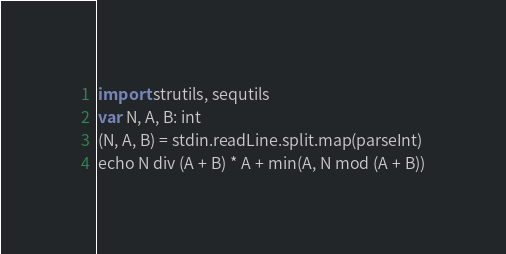Convert code to text. <code><loc_0><loc_0><loc_500><loc_500><_Nim_>import strutils, sequtils
var N, A, B: int
(N, A, B) = stdin.readLine.split.map(parseInt)
echo N div (A + B) * A + min(A, N mod (A + B))</code> 